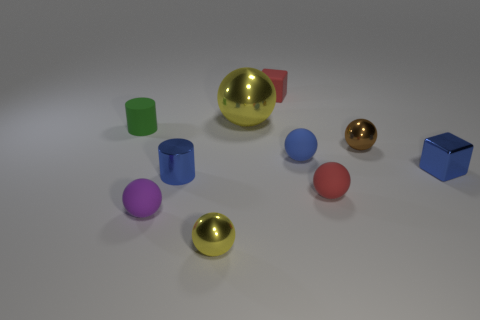There is a tiny yellow object that is the same shape as the purple object; what material is it?
Keep it short and to the point. Metal. There is a brown sphere that is the same material as the tiny blue cylinder; what is its size?
Provide a short and direct response. Small. Does the small shiny object on the right side of the brown ball have the same shape as the tiny matte object that is in front of the red matte sphere?
Your answer should be very brief. No. There is a tiny cylinder that is made of the same material as the small yellow object; what color is it?
Your answer should be very brief. Blue. There is a yellow metal thing that is in front of the purple thing; is its size the same as the red matte object that is in front of the big yellow object?
Your response must be concise. Yes. There is a object that is on the right side of the big shiny object and behind the tiny green matte cylinder; what is its shape?
Your answer should be compact. Cube. Is there a tiny blue cylinder that has the same material as the tiny blue block?
Your response must be concise. Yes. What material is the tiny sphere that is the same color as the big shiny thing?
Ensure brevity in your answer.  Metal. Is the material of the block left of the red sphere the same as the tiny blue block right of the small yellow thing?
Give a very brief answer. No. Is the number of shiny blocks greater than the number of shiny spheres?
Make the answer very short. No. 